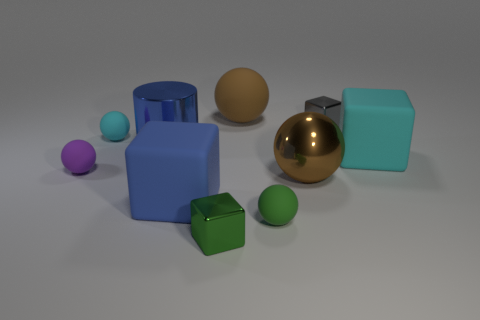The other big matte object that is the same shape as the big cyan rubber object is what color? The other large matte object with the same cubical shape as the big cyan rubber one is colored blue, reflecting a non-glossy finish. 